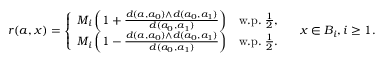<formula> <loc_0><loc_0><loc_500><loc_500>r ( a , x ) = \left \{ \begin{array} { l l } { M _ { i } \left ( 1 + \frac { d ( a , a _ { 0 } ) \wedge d ( a _ { 0 } , a _ { 1 } ) } { d ( a _ { 0 } , a _ { 1 } ) } \right ) } & { w . p . \, \frac { 1 } { 2 } , } \\ { M _ { i } \left ( 1 - \frac { d ( a , a _ { 0 } ) \wedge d ( a _ { 0 } , a _ { 1 } ) } { d ( a _ { 0 } , a _ { 1 } ) } \right ) } & { w . p . \, \frac { 1 } { 2 } . } \end{array} \quad x \in B _ { i } , i \geq 1 .</formula> 